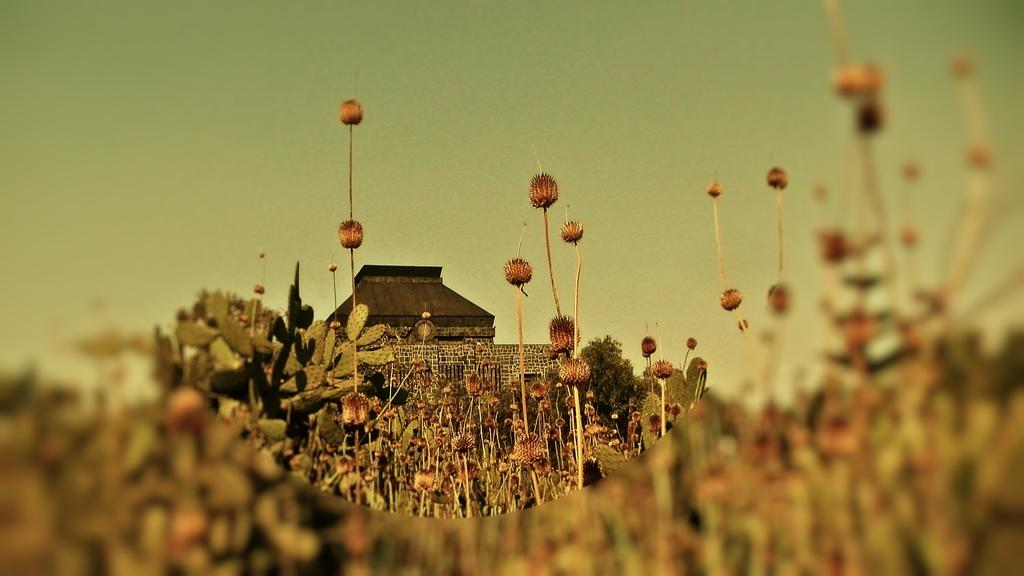What type of vegetation can be seen in the image? There are flowers, plants, and trees in the image. What type of structure is present in the image? There is a house in the image. What is visible in the background of the image? The sky is visible in the image. Can you tell me where the key is located in the image? There is no key present in the image. What type of balance is being maintained by the flowers in the image? There is no balance being maintained by the flowers in the image; they are simply plants growing in their natural state. 